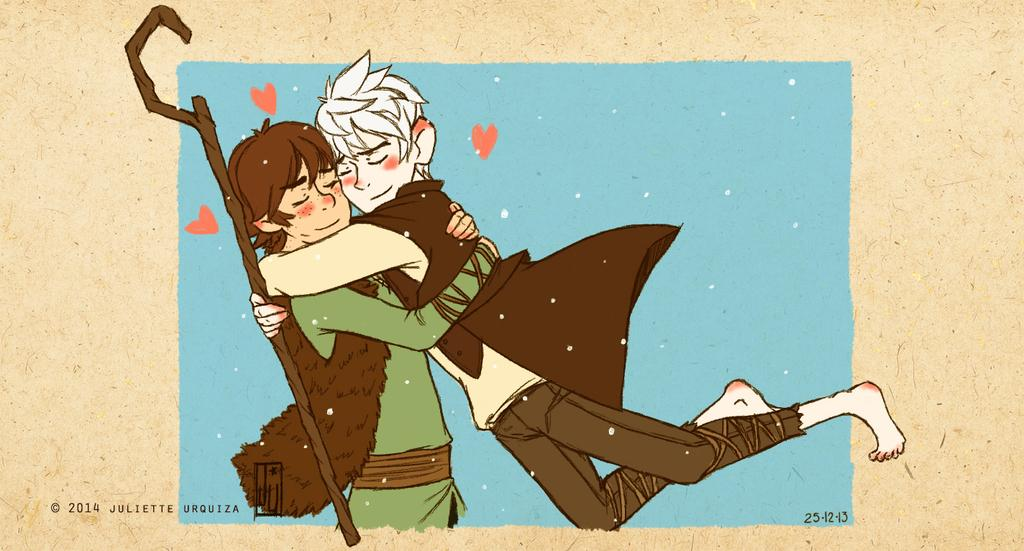How many people are in the image? There are two men in the image. What are the two men doing in the image? The two men are holding each other. Can you describe any objects that one of the men is holding? One person is holding a stick in his hand. Is there any text present in the image? Yes, there is some text in the bottom left corner of the image. What type of destruction is being caused by the goldfish in the image? There is no goldfish present in the image, so no destruction can be observed. 